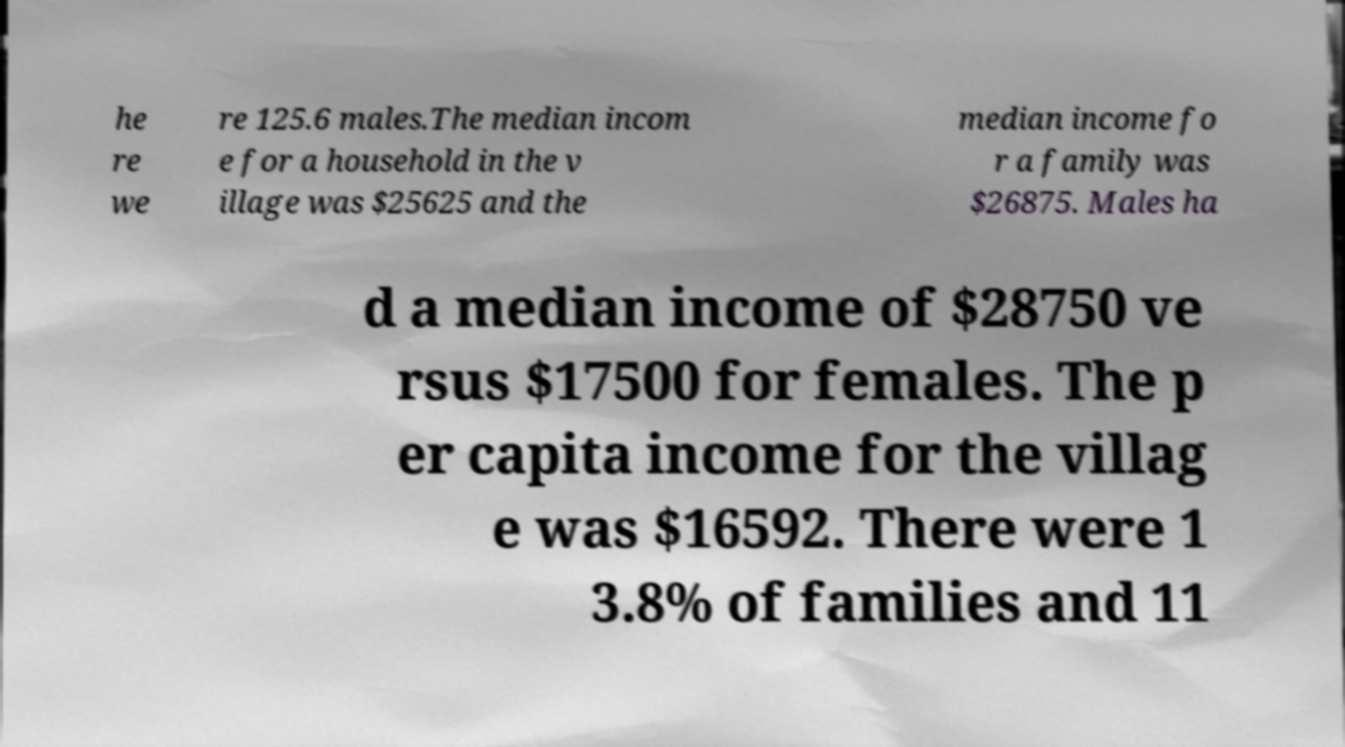What messages or text are displayed in this image? I need them in a readable, typed format. he re we re 125.6 males.The median incom e for a household in the v illage was $25625 and the median income fo r a family was $26875. Males ha d a median income of $28750 ve rsus $17500 for females. The p er capita income for the villag e was $16592. There were 1 3.8% of families and 11 